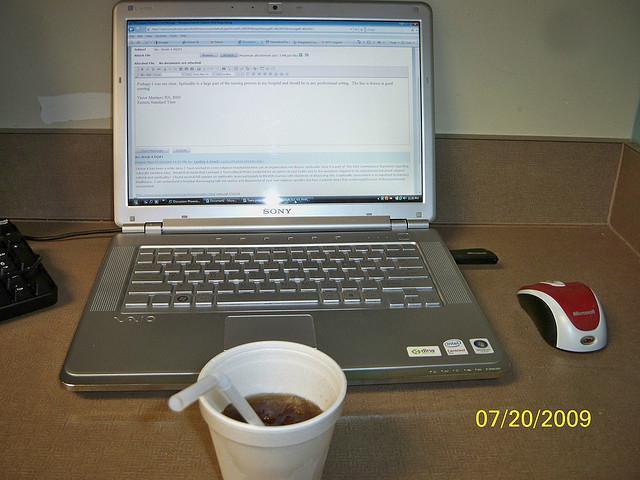How many mugs are on the table?
Give a very brief answer. 1. How many mice can be seen?
Give a very brief answer. 1. How many keyboards are there?
Give a very brief answer. 2. 